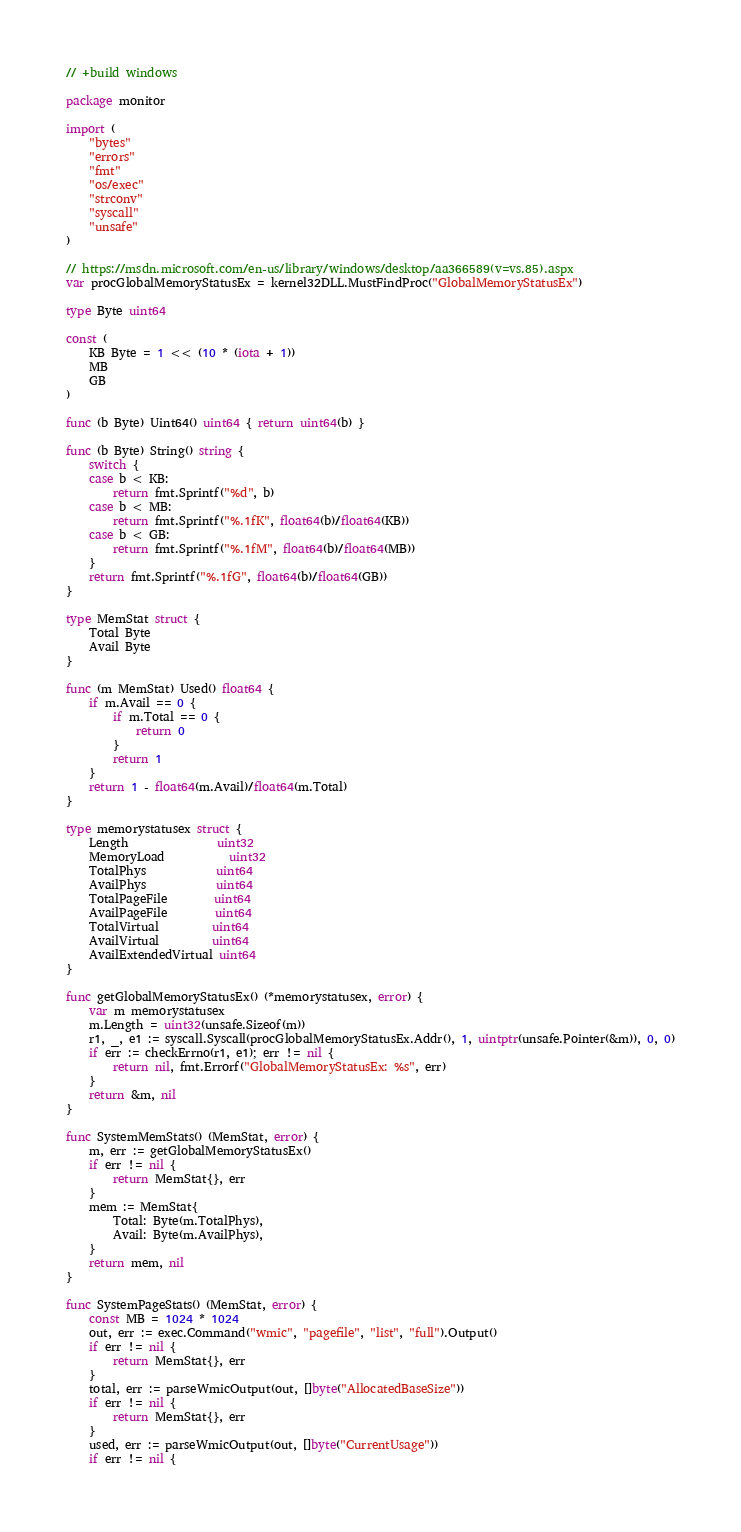Convert code to text. <code><loc_0><loc_0><loc_500><loc_500><_Go_>// +build windows

package monitor

import (
	"bytes"
	"errors"
	"fmt"
	"os/exec"
	"strconv"
	"syscall"
	"unsafe"
)

// https://msdn.microsoft.com/en-us/library/windows/desktop/aa366589(v=vs.85).aspx
var procGlobalMemoryStatusEx = kernel32DLL.MustFindProc("GlobalMemoryStatusEx")

type Byte uint64

const (
	KB Byte = 1 << (10 * (iota + 1))
	MB
	GB
)

func (b Byte) Uint64() uint64 { return uint64(b) }

func (b Byte) String() string {
	switch {
	case b < KB:
		return fmt.Sprintf("%d", b)
	case b < MB:
		return fmt.Sprintf("%.1fK", float64(b)/float64(KB))
	case b < GB:
		return fmt.Sprintf("%.1fM", float64(b)/float64(MB))
	}
	return fmt.Sprintf("%.1fG", float64(b)/float64(GB))
}

type MemStat struct {
	Total Byte
	Avail Byte
}

func (m MemStat) Used() float64 {
	if m.Avail == 0 {
		if m.Total == 0 {
			return 0
		}
		return 1
	}
	return 1 - float64(m.Avail)/float64(m.Total)
}

type memorystatusex struct {
	Length               uint32
	MemoryLoad           uint32
	TotalPhys            uint64
	AvailPhys            uint64
	TotalPageFile        uint64
	AvailPageFile        uint64
	TotalVirtual         uint64
	AvailVirtual         uint64
	AvailExtendedVirtual uint64
}

func getGlobalMemoryStatusEx() (*memorystatusex, error) {
	var m memorystatusex
	m.Length = uint32(unsafe.Sizeof(m))
	r1, _, e1 := syscall.Syscall(procGlobalMemoryStatusEx.Addr(), 1, uintptr(unsafe.Pointer(&m)), 0, 0)
	if err := checkErrno(r1, e1); err != nil {
		return nil, fmt.Errorf("GlobalMemoryStatusEx: %s", err)
	}
	return &m, nil
}

func SystemMemStats() (MemStat, error) {
	m, err := getGlobalMemoryStatusEx()
	if err != nil {
		return MemStat{}, err
	}
	mem := MemStat{
		Total: Byte(m.TotalPhys),
		Avail: Byte(m.AvailPhys),
	}
	return mem, nil
}

func SystemPageStats() (MemStat, error) {
	const MB = 1024 * 1024
	out, err := exec.Command("wmic", "pagefile", "list", "full").Output()
	if err != nil {
		return MemStat{}, err
	}
	total, err := parseWmicOutput(out, []byte("AllocatedBaseSize"))
	if err != nil {
		return MemStat{}, err
	}
	used, err := parseWmicOutput(out, []byte("CurrentUsage"))
	if err != nil {</code> 